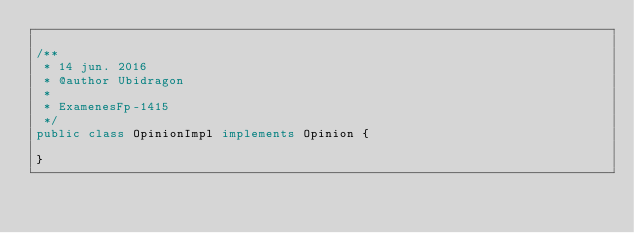<code> <loc_0><loc_0><loc_500><loc_500><_Java_>
/**
 * 14 jun. 2016
 * @author Ubidragon
 *
 * ExamenesFp-1415
 */
public class OpinionImpl implements Opinion {

}
</code> 